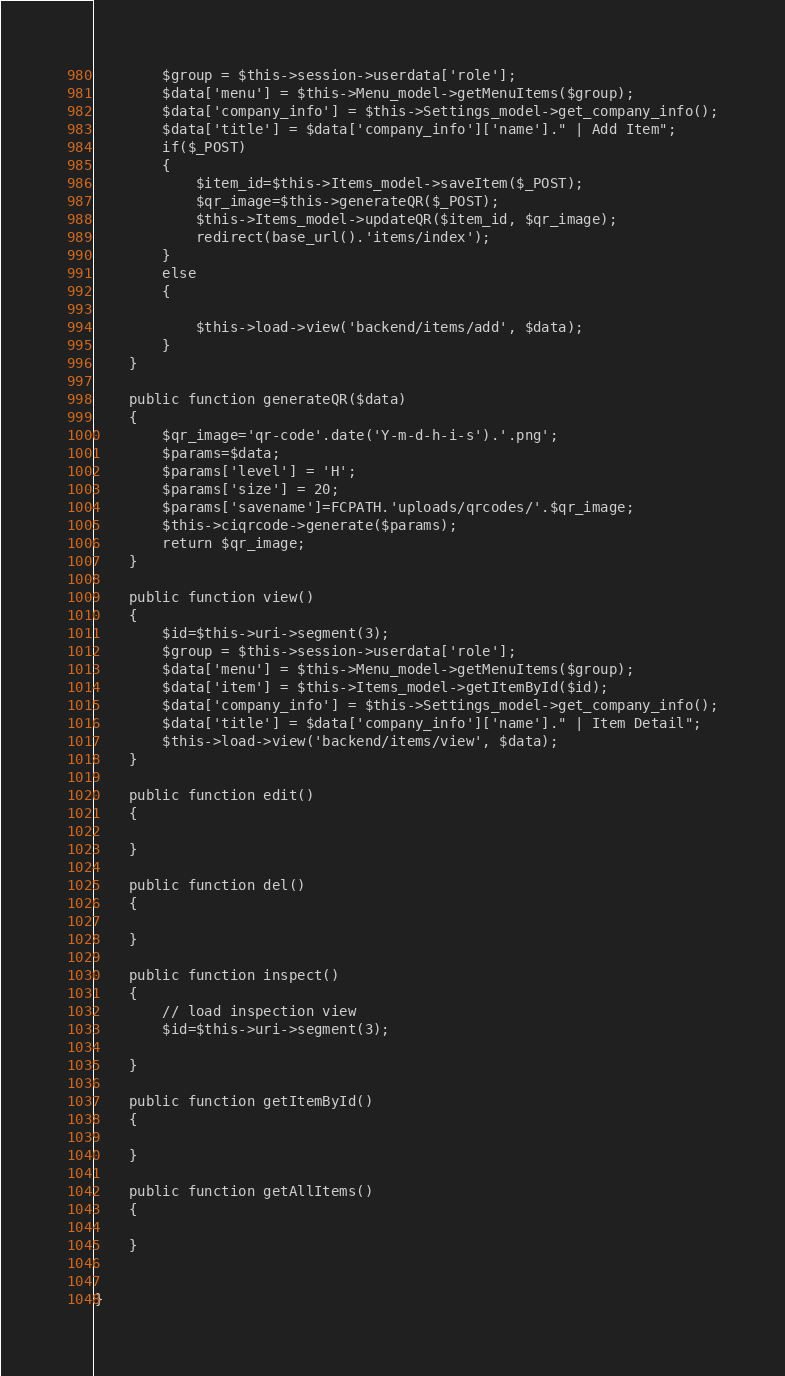Convert code to text. <code><loc_0><loc_0><loc_500><loc_500><_PHP_>        $group = $this->session->userdata['role'];
        $data['menu'] = $this->Menu_model->getMenuItems($group);
        $data['company_info'] = $this->Settings_model->get_company_info();
        $data['title'] = $data['company_info']['name']." | Add Item";
        if($_POST)
        {
            $item_id=$this->Items_model->saveItem($_POST);
            $qr_image=$this->generateQR($_POST);
            $this->Items_model->updateQR($item_id, $qr_image);
            redirect(base_url().'items/index');
        }
        else
        {
            
            $this->load->view('backend/items/add', $data);
        }
    }

    public function generateQR($data)
    {
        $qr_image='qr-code'.date('Y-m-d-h-i-s').'.png';
        $params=$data;
        $params['level'] = 'H';
        $params['size'] = 20;
        $params['savename']=FCPATH.'uploads/qrcodes/'.$qr_image;
        $this->ciqrcode->generate($params);
        return $qr_image;
    }

    public function view()
    {
        $id=$this->uri->segment(3);
        $group = $this->session->userdata['role'];
        $data['menu'] = $this->Menu_model->getMenuItems($group);
        $data['item'] = $this->Items_model->getItemById($id);
        $data['company_info'] = $this->Settings_model->get_company_info();
        $data['title'] = $data['company_info']['name']." | Item Detail";
        $this->load->view('backend/items/view', $data);
    }

    public function edit()
    {

    }

    public function del()
    {

    }

    public function inspect()
    {
        // load inspection view
        $id=$this->uri->segment(3);
        
    }

    public function getItemById()
    {

    }

    public function getAllItems()
    {

    }

    
}
</code> 